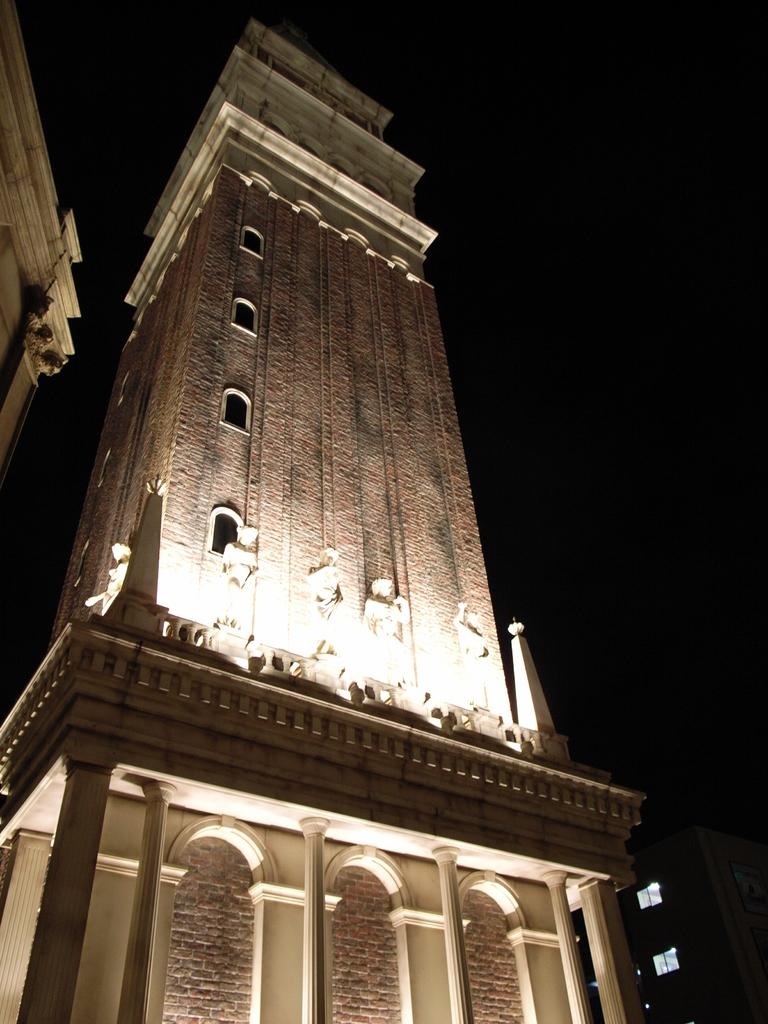What can be found in the center of the image? There are statues in the middle of the image. What type of structure is present in the image? There is a building with lights in the image. What part of the sky is visible in the image? The sky is visible on the right side of the image. How many apples are on the chessboard in the image? There is no chessboard or apples present in the image. What type of crack can be seen on the statues in the image? There are no cracks visible on the statues in the image. 